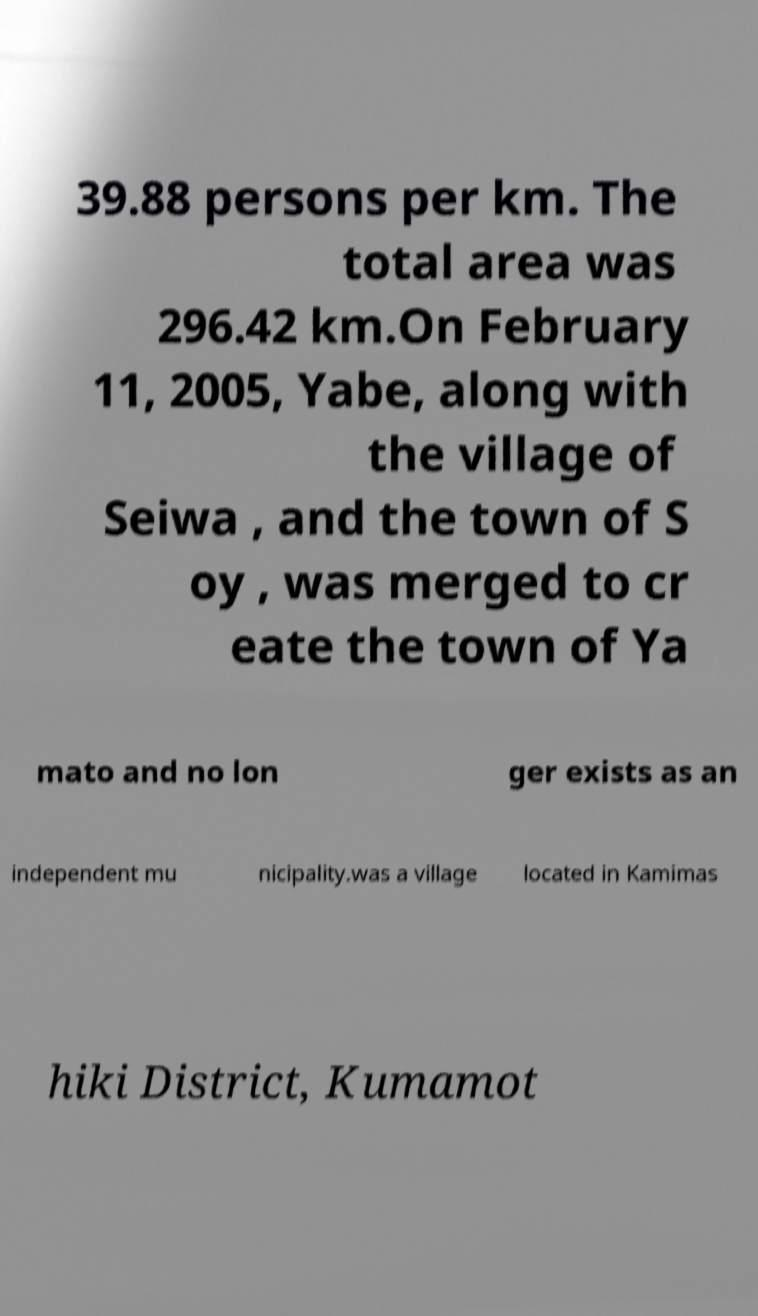For documentation purposes, I need the text within this image transcribed. Could you provide that? 39.88 persons per km. The total area was 296.42 km.On February 11, 2005, Yabe, along with the village of Seiwa , and the town of S oy , was merged to cr eate the town of Ya mato and no lon ger exists as an independent mu nicipality.was a village located in Kamimas hiki District, Kumamot 